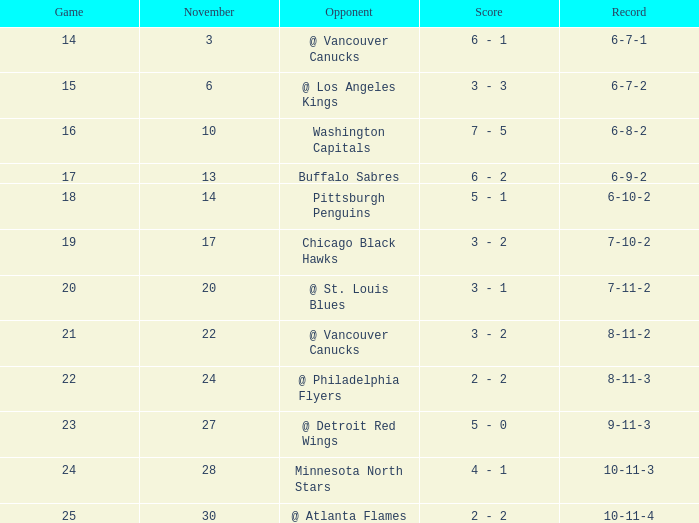Help me parse the entirety of this table. {'header': ['Game', 'November', 'Opponent', 'Score', 'Record'], 'rows': [['14', '3', '@ Vancouver Canucks', '6 - 1', '6-7-1'], ['15', '6', '@ Los Angeles Kings', '3 - 3', '6-7-2'], ['16', '10', 'Washington Capitals', '7 - 5', '6-8-2'], ['17', '13', 'Buffalo Sabres', '6 - 2', '6-9-2'], ['18', '14', 'Pittsburgh Penguins', '5 - 1', '6-10-2'], ['19', '17', 'Chicago Black Hawks', '3 - 2', '7-10-2'], ['20', '20', '@ St. Louis Blues', '3 - 1', '7-11-2'], ['21', '22', '@ Vancouver Canucks', '3 - 2', '8-11-2'], ['22', '24', '@ Philadelphia Flyers', '2 - 2', '8-11-3'], ['23', '27', '@ Detroit Red Wings', '5 - 0', '9-11-3'], ['24', '28', 'Minnesota North Stars', '4 - 1', '10-11-3'], ['25', '30', '@ Atlanta Flames', '2 - 2', '10-11-4']]} Who is the rival on november 24? @ Philadelphia Flyers. 